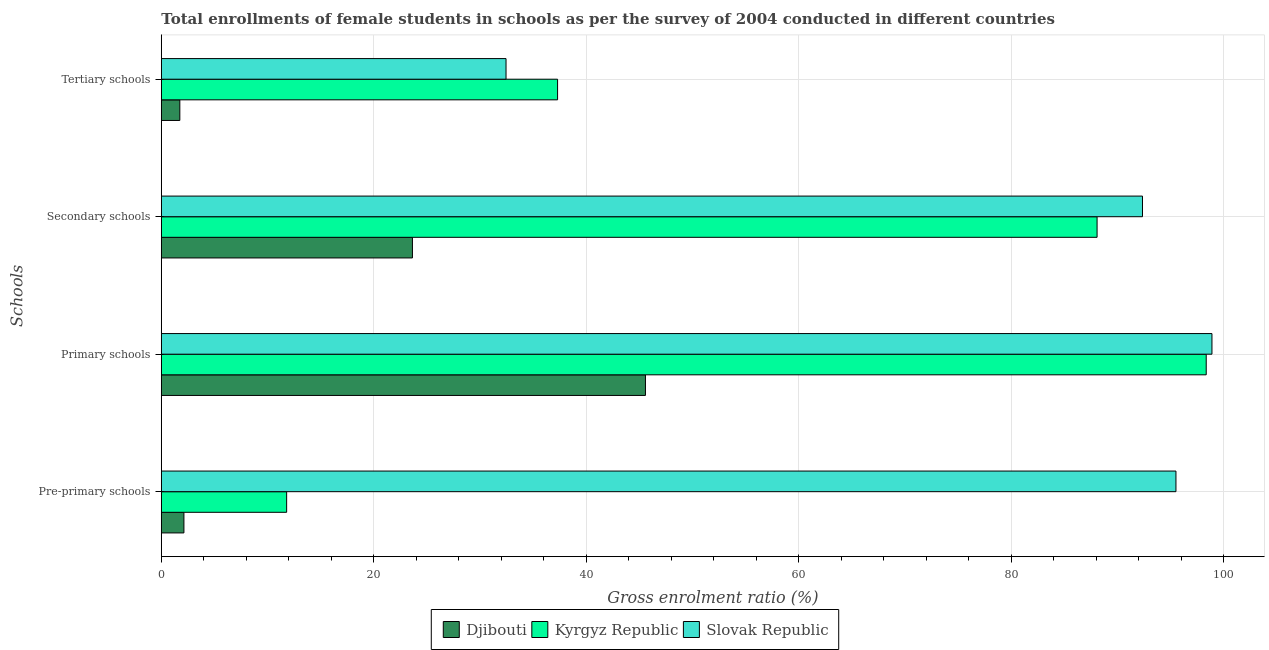How many different coloured bars are there?
Your answer should be very brief. 3. How many groups of bars are there?
Offer a terse response. 4. Are the number of bars on each tick of the Y-axis equal?
Provide a short and direct response. Yes. What is the label of the 3rd group of bars from the top?
Your response must be concise. Primary schools. What is the gross enrolment ratio(female) in pre-primary schools in Slovak Republic?
Your answer should be very brief. 95.48. Across all countries, what is the maximum gross enrolment ratio(female) in pre-primary schools?
Offer a terse response. 95.48. Across all countries, what is the minimum gross enrolment ratio(female) in tertiary schools?
Offer a terse response. 1.74. In which country was the gross enrolment ratio(female) in pre-primary schools maximum?
Provide a succinct answer. Slovak Republic. In which country was the gross enrolment ratio(female) in tertiary schools minimum?
Your answer should be very brief. Djibouti. What is the total gross enrolment ratio(female) in pre-primary schools in the graph?
Offer a very short reply. 109.4. What is the difference between the gross enrolment ratio(female) in primary schools in Djibouti and that in Slovak Republic?
Provide a short and direct response. -53.31. What is the difference between the gross enrolment ratio(female) in tertiary schools in Slovak Republic and the gross enrolment ratio(female) in pre-primary schools in Djibouti?
Make the answer very short. 30.31. What is the average gross enrolment ratio(female) in tertiary schools per country?
Provide a succinct answer. 23.82. What is the difference between the gross enrolment ratio(female) in secondary schools and gross enrolment ratio(female) in primary schools in Djibouti?
Provide a short and direct response. -21.93. What is the ratio of the gross enrolment ratio(female) in primary schools in Kyrgyz Republic to that in Djibouti?
Make the answer very short. 2.16. What is the difference between the highest and the second highest gross enrolment ratio(female) in secondary schools?
Ensure brevity in your answer.  4.27. What is the difference between the highest and the lowest gross enrolment ratio(female) in pre-primary schools?
Your response must be concise. 93.35. In how many countries, is the gross enrolment ratio(female) in tertiary schools greater than the average gross enrolment ratio(female) in tertiary schools taken over all countries?
Make the answer very short. 2. Is the sum of the gross enrolment ratio(female) in tertiary schools in Djibouti and Kyrgyz Republic greater than the maximum gross enrolment ratio(female) in primary schools across all countries?
Make the answer very short. No. What does the 2nd bar from the top in Primary schools represents?
Offer a terse response. Kyrgyz Republic. What does the 2nd bar from the bottom in Secondary schools represents?
Provide a short and direct response. Kyrgyz Republic. Are all the bars in the graph horizontal?
Make the answer very short. Yes. What is the difference between two consecutive major ticks on the X-axis?
Ensure brevity in your answer.  20. Are the values on the major ticks of X-axis written in scientific E-notation?
Offer a very short reply. No. Does the graph contain grids?
Your response must be concise. Yes. How many legend labels are there?
Your answer should be very brief. 3. How are the legend labels stacked?
Provide a succinct answer. Horizontal. What is the title of the graph?
Give a very brief answer. Total enrollments of female students in schools as per the survey of 2004 conducted in different countries. Does "Congo (Democratic)" appear as one of the legend labels in the graph?
Keep it short and to the point. No. What is the label or title of the Y-axis?
Provide a short and direct response. Schools. What is the Gross enrolment ratio (%) in Djibouti in Pre-primary schools?
Provide a short and direct response. 2.13. What is the Gross enrolment ratio (%) in Kyrgyz Republic in Pre-primary schools?
Provide a short and direct response. 11.79. What is the Gross enrolment ratio (%) of Slovak Republic in Pre-primary schools?
Offer a terse response. 95.48. What is the Gross enrolment ratio (%) of Djibouti in Primary schools?
Your answer should be compact. 45.56. What is the Gross enrolment ratio (%) in Kyrgyz Republic in Primary schools?
Offer a very short reply. 98.33. What is the Gross enrolment ratio (%) in Slovak Republic in Primary schools?
Give a very brief answer. 98.87. What is the Gross enrolment ratio (%) of Djibouti in Secondary schools?
Offer a very short reply. 23.63. What is the Gross enrolment ratio (%) of Kyrgyz Republic in Secondary schools?
Offer a terse response. 88.06. What is the Gross enrolment ratio (%) in Slovak Republic in Secondary schools?
Make the answer very short. 92.33. What is the Gross enrolment ratio (%) in Djibouti in Tertiary schools?
Ensure brevity in your answer.  1.74. What is the Gross enrolment ratio (%) in Kyrgyz Republic in Tertiary schools?
Provide a succinct answer. 37.29. What is the Gross enrolment ratio (%) in Slovak Republic in Tertiary schools?
Provide a succinct answer. 32.44. Across all Schools, what is the maximum Gross enrolment ratio (%) in Djibouti?
Provide a succinct answer. 45.56. Across all Schools, what is the maximum Gross enrolment ratio (%) of Kyrgyz Republic?
Provide a short and direct response. 98.33. Across all Schools, what is the maximum Gross enrolment ratio (%) in Slovak Republic?
Ensure brevity in your answer.  98.87. Across all Schools, what is the minimum Gross enrolment ratio (%) of Djibouti?
Make the answer very short. 1.74. Across all Schools, what is the minimum Gross enrolment ratio (%) of Kyrgyz Republic?
Your answer should be very brief. 11.79. Across all Schools, what is the minimum Gross enrolment ratio (%) in Slovak Republic?
Your answer should be compact. 32.44. What is the total Gross enrolment ratio (%) of Djibouti in the graph?
Offer a very short reply. 73.06. What is the total Gross enrolment ratio (%) of Kyrgyz Republic in the graph?
Offer a terse response. 235.47. What is the total Gross enrolment ratio (%) in Slovak Republic in the graph?
Give a very brief answer. 319.12. What is the difference between the Gross enrolment ratio (%) of Djibouti in Pre-primary schools and that in Primary schools?
Your answer should be compact. -43.43. What is the difference between the Gross enrolment ratio (%) in Kyrgyz Republic in Pre-primary schools and that in Primary schools?
Offer a very short reply. -86.54. What is the difference between the Gross enrolment ratio (%) in Slovak Republic in Pre-primary schools and that in Primary schools?
Your response must be concise. -3.39. What is the difference between the Gross enrolment ratio (%) in Djibouti in Pre-primary schools and that in Secondary schools?
Offer a very short reply. -21.5. What is the difference between the Gross enrolment ratio (%) of Kyrgyz Republic in Pre-primary schools and that in Secondary schools?
Make the answer very short. -76.27. What is the difference between the Gross enrolment ratio (%) of Slovak Republic in Pre-primary schools and that in Secondary schools?
Your answer should be very brief. 3.15. What is the difference between the Gross enrolment ratio (%) of Djibouti in Pre-primary schools and that in Tertiary schools?
Your response must be concise. 0.38. What is the difference between the Gross enrolment ratio (%) of Kyrgyz Republic in Pre-primary schools and that in Tertiary schools?
Provide a short and direct response. -25.5. What is the difference between the Gross enrolment ratio (%) in Slovak Republic in Pre-primary schools and that in Tertiary schools?
Your response must be concise. 63.04. What is the difference between the Gross enrolment ratio (%) of Djibouti in Primary schools and that in Secondary schools?
Ensure brevity in your answer.  21.93. What is the difference between the Gross enrolment ratio (%) of Kyrgyz Republic in Primary schools and that in Secondary schools?
Offer a terse response. 10.27. What is the difference between the Gross enrolment ratio (%) in Slovak Republic in Primary schools and that in Secondary schools?
Your answer should be very brief. 6.54. What is the difference between the Gross enrolment ratio (%) of Djibouti in Primary schools and that in Tertiary schools?
Your answer should be very brief. 43.82. What is the difference between the Gross enrolment ratio (%) of Kyrgyz Republic in Primary schools and that in Tertiary schools?
Your answer should be compact. 61.04. What is the difference between the Gross enrolment ratio (%) of Slovak Republic in Primary schools and that in Tertiary schools?
Your answer should be compact. 66.43. What is the difference between the Gross enrolment ratio (%) of Djibouti in Secondary schools and that in Tertiary schools?
Make the answer very short. 21.89. What is the difference between the Gross enrolment ratio (%) in Kyrgyz Republic in Secondary schools and that in Tertiary schools?
Make the answer very short. 50.77. What is the difference between the Gross enrolment ratio (%) of Slovak Republic in Secondary schools and that in Tertiary schools?
Your response must be concise. 59.89. What is the difference between the Gross enrolment ratio (%) of Djibouti in Pre-primary schools and the Gross enrolment ratio (%) of Kyrgyz Republic in Primary schools?
Your answer should be compact. -96.2. What is the difference between the Gross enrolment ratio (%) of Djibouti in Pre-primary schools and the Gross enrolment ratio (%) of Slovak Republic in Primary schools?
Ensure brevity in your answer.  -96.74. What is the difference between the Gross enrolment ratio (%) of Kyrgyz Republic in Pre-primary schools and the Gross enrolment ratio (%) of Slovak Republic in Primary schools?
Ensure brevity in your answer.  -87.08. What is the difference between the Gross enrolment ratio (%) of Djibouti in Pre-primary schools and the Gross enrolment ratio (%) of Kyrgyz Republic in Secondary schools?
Your answer should be very brief. -85.93. What is the difference between the Gross enrolment ratio (%) in Djibouti in Pre-primary schools and the Gross enrolment ratio (%) in Slovak Republic in Secondary schools?
Offer a terse response. -90.21. What is the difference between the Gross enrolment ratio (%) in Kyrgyz Republic in Pre-primary schools and the Gross enrolment ratio (%) in Slovak Republic in Secondary schools?
Your answer should be very brief. -80.54. What is the difference between the Gross enrolment ratio (%) in Djibouti in Pre-primary schools and the Gross enrolment ratio (%) in Kyrgyz Republic in Tertiary schools?
Offer a very short reply. -35.16. What is the difference between the Gross enrolment ratio (%) of Djibouti in Pre-primary schools and the Gross enrolment ratio (%) of Slovak Republic in Tertiary schools?
Your answer should be compact. -30.31. What is the difference between the Gross enrolment ratio (%) of Kyrgyz Republic in Pre-primary schools and the Gross enrolment ratio (%) of Slovak Republic in Tertiary schools?
Offer a terse response. -20.65. What is the difference between the Gross enrolment ratio (%) of Djibouti in Primary schools and the Gross enrolment ratio (%) of Kyrgyz Republic in Secondary schools?
Provide a succinct answer. -42.5. What is the difference between the Gross enrolment ratio (%) in Djibouti in Primary schools and the Gross enrolment ratio (%) in Slovak Republic in Secondary schools?
Provide a short and direct response. -46.77. What is the difference between the Gross enrolment ratio (%) of Kyrgyz Republic in Primary schools and the Gross enrolment ratio (%) of Slovak Republic in Secondary schools?
Give a very brief answer. 6. What is the difference between the Gross enrolment ratio (%) in Djibouti in Primary schools and the Gross enrolment ratio (%) in Kyrgyz Republic in Tertiary schools?
Provide a short and direct response. 8.27. What is the difference between the Gross enrolment ratio (%) in Djibouti in Primary schools and the Gross enrolment ratio (%) in Slovak Republic in Tertiary schools?
Make the answer very short. 13.12. What is the difference between the Gross enrolment ratio (%) in Kyrgyz Republic in Primary schools and the Gross enrolment ratio (%) in Slovak Republic in Tertiary schools?
Give a very brief answer. 65.89. What is the difference between the Gross enrolment ratio (%) of Djibouti in Secondary schools and the Gross enrolment ratio (%) of Kyrgyz Republic in Tertiary schools?
Your answer should be very brief. -13.66. What is the difference between the Gross enrolment ratio (%) in Djibouti in Secondary schools and the Gross enrolment ratio (%) in Slovak Republic in Tertiary schools?
Give a very brief answer. -8.81. What is the difference between the Gross enrolment ratio (%) of Kyrgyz Republic in Secondary schools and the Gross enrolment ratio (%) of Slovak Republic in Tertiary schools?
Offer a very short reply. 55.62. What is the average Gross enrolment ratio (%) of Djibouti per Schools?
Keep it short and to the point. 18.27. What is the average Gross enrolment ratio (%) of Kyrgyz Republic per Schools?
Give a very brief answer. 58.87. What is the average Gross enrolment ratio (%) of Slovak Republic per Schools?
Provide a succinct answer. 79.78. What is the difference between the Gross enrolment ratio (%) in Djibouti and Gross enrolment ratio (%) in Kyrgyz Republic in Pre-primary schools?
Make the answer very short. -9.67. What is the difference between the Gross enrolment ratio (%) in Djibouti and Gross enrolment ratio (%) in Slovak Republic in Pre-primary schools?
Give a very brief answer. -93.35. What is the difference between the Gross enrolment ratio (%) of Kyrgyz Republic and Gross enrolment ratio (%) of Slovak Republic in Pre-primary schools?
Make the answer very short. -83.69. What is the difference between the Gross enrolment ratio (%) of Djibouti and Gross enrolment ratio (%) of Kyrgyz Republic in Primary schools?
Keep it short and to the point. -52.77. What is the difference between the Gross enrolment ratio (%) of Djibouti and Gross enrolment ratio (%) of Slovak Republic in Primary schools?
Offer a very short reply. -53.31. What is the difference between the Gross enrolment ratio (%) of Kyrgyz Republic and Gross enrolment ratio (%) of Slovak Republic in Primary schools?
Your response must be concise. -0.54. What is the difference between the Gross enrolment ratio (%) in Djibouti and Gross enrolment ratio (%) in Kyrgyz Republic in Secondary schools?
Keep it short and to the point. -64.43. What is the difference between the Gross enrolment ratio (%) of Djibouti and Gross enrolment ratio (%) of Slovak Republic in Secondary schools?
Your answer should be compact. -68.7. What is the difference between the Gross enrolment ratio (%) of Kyrgyz Republic and Gross enrolment ratio (%) of Slovak Republic in Secondary schools?
Ensure brevity in your answer.  -4.27. What is the difference between the Gross enrolment ratio (%) in Djibouti and Gross enrolment ratio (%) in Kyrgyz Republic in Tertiary schools?
Your answer should be very brief. -35.55. What is the difference between the Gross enrolment ratio (%) in Djibouti and Gross enrolment ratio (%) in Slovak Republic in Tertiary schools?
Make the answer very short. -30.7. What is the difference between the Gross enrolment ratio (%) of Kyrgyz Republic and Gross enrolment ratio (%) of Slovak Republic in Tertiary schools?
Ensure brevity in your answer.  4.85. What is the ratio of the Gross enrolment ratio (%) of Djibouti in Pre-primary schools to that in Primary schools?
Keep it short and to the point. 0.05. What is the ratio of the Gross enrolment ratio (%) of Kyrgyz Republic in Pre-primary schools to that in Primary schools?
Make the answer very short. 0.12. What is the ratio of the Gross enrolment ratio (%) of Slovak Republic in Pre-primary schools to that in Primary schools?
Offer a very short reply. 0.97. What is the ratio of the Gross enrolment ratio (%) of Djibouti in Pre-primary schools to that in Secondary schools?
Keep it short and to the point. 0.09. What is the ratio of the Gross enrolment ratio (%) of Kyrgyz Republic in Pre-primary schools to that in Secondary schools?
Your answer should be very brief. 0.13. What is the ratio of the Gross enrolment ratio (%) in Slovak Republic in Pre-primary schools to that in Secondary schools?
Keep it short and to the point. 1.03. What is the ratio of the Gross enrolment ratio (%) in Djibouti in Pre-primary schools to that in Tertiary schools?
Your answer should be compact. 1.22. What is the ratio of the Gross enrolment ratio (%) of Kyrgyz Republic in Pre-primary schools to that in Tertiary schools?
Provide a short and direct response. 0.32. What is the ratio of the Gross enrolment ratio (%) of Slovak Republic in Pre-primary schools to that in Tertiary schools?
Your answer should be very brief. 2.94. What is the ratio of the Gross enrolment ratio (%) of Djibouti in Primary schools to that in Secondary schools?
Provide a short and direct response. 1.93. What is the ratio of the Gross enrolment ratio (%) in Kyrgyz Republic in Primary schools to that in Secondary schools?
Offer a terse response. 1.12. What is the ratio of the Gross enrolment ratio (%) in Slovak Republic in Primary schools to that in Secondary schools?
Provide a succinct answer. 1.07. What is the ratio of the Gross enrolment ratio (%) in Djibouti in Primary schools to that in Tertiary schools?
Your answer should be very brief. 26.14. What is the ratio of the Gross enrolment ratio (%) of Kyrgyz Republic in Primary schools to that in Tertiary schools?
Your response must be concise. 2.64. What is the ratio of the Gross enrolment ratio (%) in Slovak Republic in Primary schools to that in Tertiary schools?
Give a very brief answer. 3.05. What is the ratio of the Gross enrolment ratio (%) in Djibouti in Secondary schools to that in Tertiary schools?
Offer a very short reply. 13.56. What is the ratio of the Gross enrolment ratio (%) in Kyrgyz Republic in Secondary schools to that in Tertiary schools?
Provide a succinct answer. 2.36. What is the ratio of the Gross enrolment ratio (%) of Slovak Republic in Secondary schools to that in Tertiary schools?
Ensure brevity in your answer.  2.85. What is the difference between the highest and the second highest Gross enrolment ratio (%) of Djibouti?
Your answer should be compact. 21.93. What is the difference between the highest and the second highest Gross enrolment ratio (%) in Kyrgyz Republic?
Offer a terse response. 10.27. What is the difference between the highest and the second highest Gross enrolment ratio (%) of Slovak Republic?
Give a very brief answer. 3.39. What is the difference between the highest and the lowest Gross enrolment ratio (%) of Djibouti?
Give a very brief answer. 43.82. What is the difference between the highest and the lowest Gross enrolment ratio (%) in Kyrgyz Republic?
Make the answer very short. 86.54. What is the difference between the highest and the lowest Gross enrolment ratio (%) in Slovak Republic?
Keep it short and to the point. 66.43. 